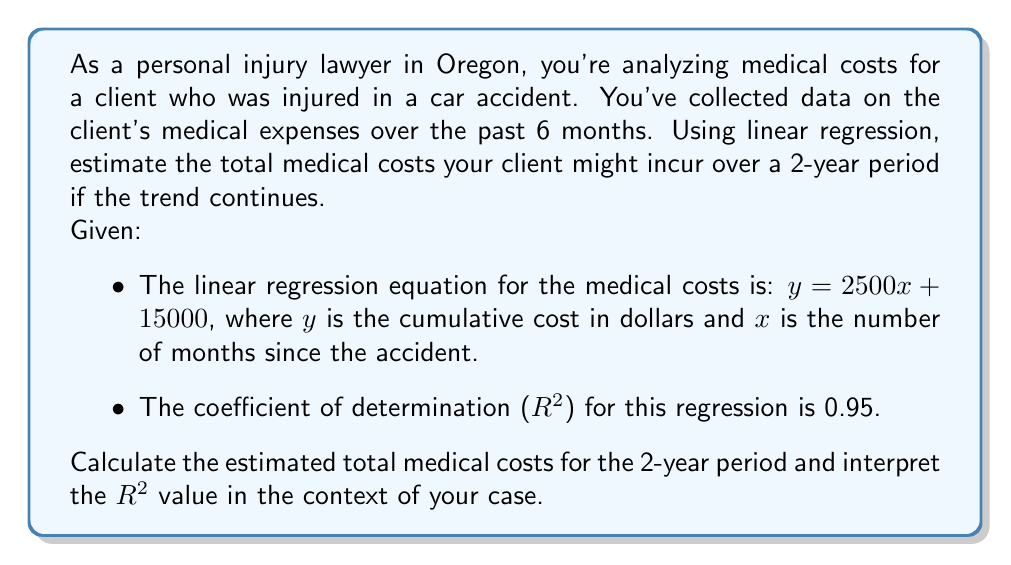Teach me how to tackle this problem. Let's approach this problem step-by-step:

1. Understanding the linear regression equation:
   $y = 2500x + 15000$
   - $y$ represents the cumulative cost in dollars
   - $x$ represents the number of months since the accident
   - The slope (2500) indicates that costs increase by $2500 per month
   - The y-intercept (15000) represents the initial costs at the time of the accident

2. Calculating the estimated costs for a 2-year period:
   - 2 years = 24 months, so we need to calculate $y$ when $x = 24$
   - Plugging in $x = 24$ into our equation:
     $$y = 2500(24) + 15000$$
     $$y = 60000 + 15000$$
     $$y = 75000$$

3. Interpreting the $R^2$ value:
   - $R^2 = 0.95$ indicates that 95% of the variance in the medical costs can be explained by the linear relationship with time.
   - This suggests a strong fit between the model and the actual data, increasing confidence in the prediction.

4. Legal implications:
   - The high $R^2$ value strengthens the case for future medical expenses.
   - The linear trend suggests ongoing medical needs, which is important for claiming future damages.
   - The initial $15,000 could represent immediate medical costs post-accident.
Answer: The estimated total medical costs for the 2-year period are $75,000. The $R^2$ value of 0.95 indicates a strong correlation between time and medical costs, suggesting high reliability in the cost projection for the personal injury case. 